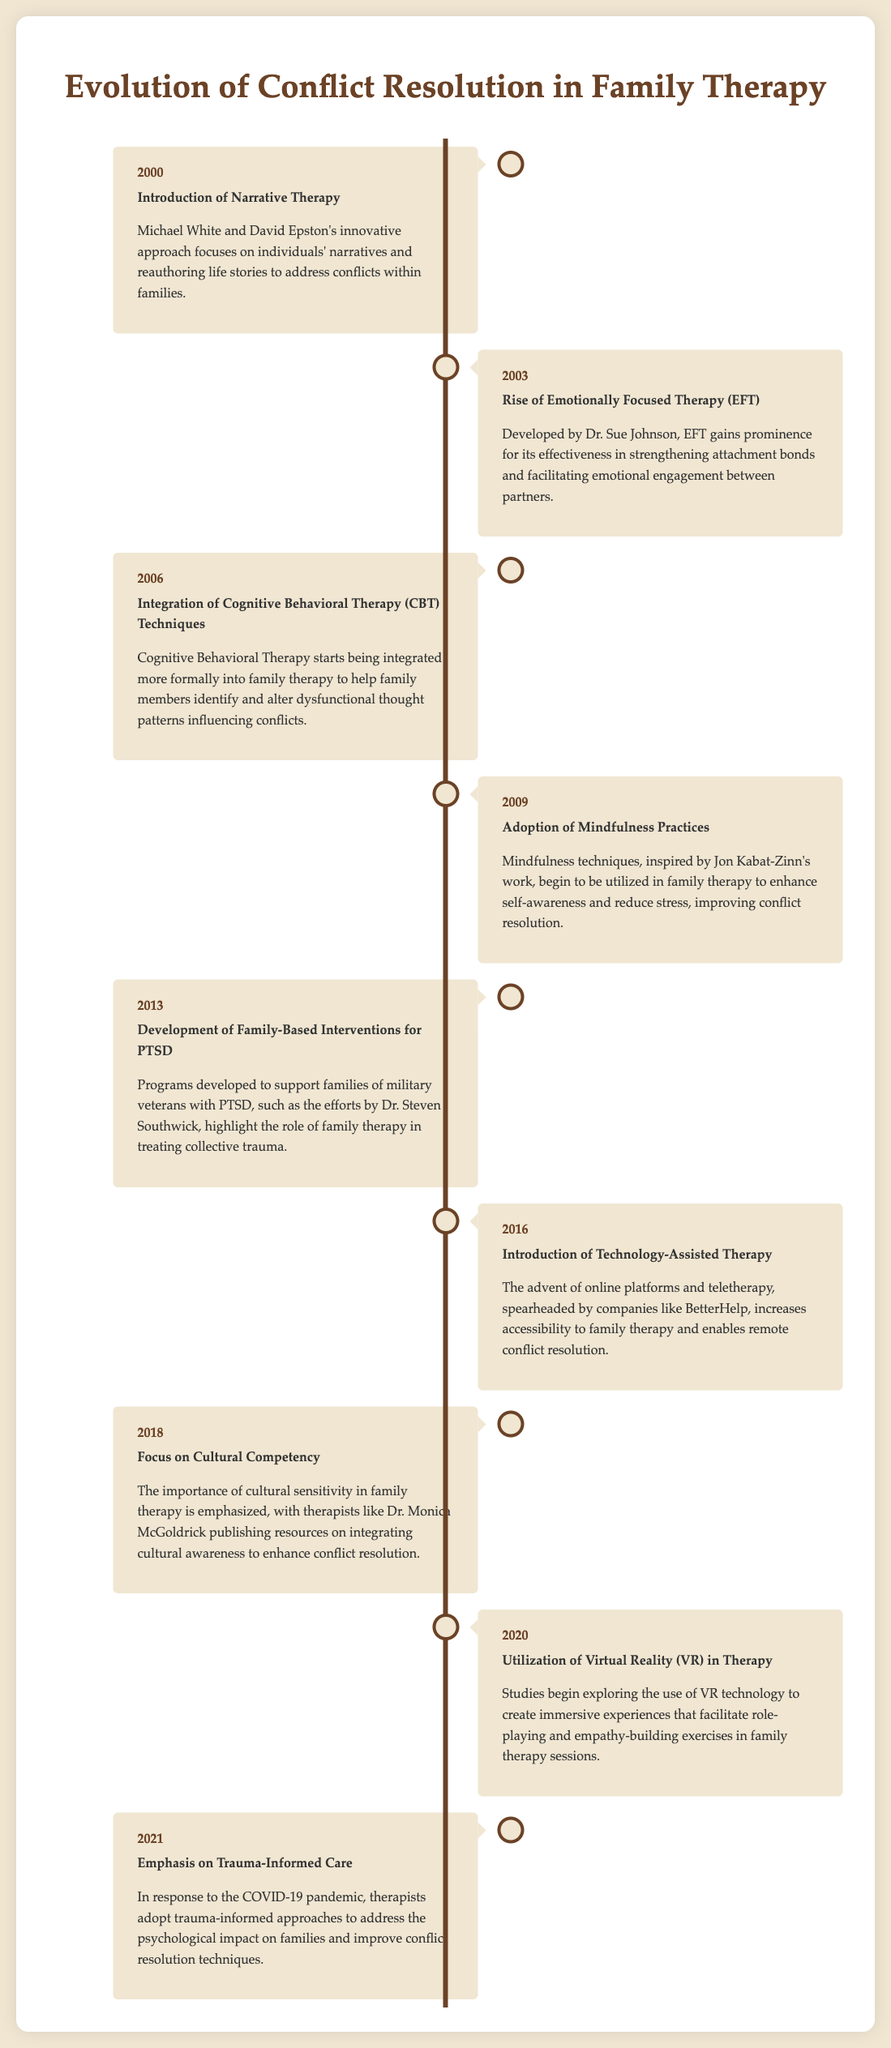What is the first milestone in the timeline? The timeline starts with the introduction of Narrative Therapy in the year 2000.
Answer: Introduction of Narrative Therapy Who developed Emotionally Focused Therapy? The document states that Dr. Sue Johnson developed Emotionally Focused Therapy in 2003.
Answer: Dr. Sue Johnson What year did mindfulness practices begin to be adopted in therapy? According to the timeline, mindfulness practices began to be adopted in family therapy in 2009.
Answer: 2009 Which milestone focuses on cultural competency? The timeline mentions a focus on Cultural Competency as a milestone in 2018.
Answer: Focus on Cultural Competency In what year was trauma-informed care emphasized? The emphasis on trauma-informed care in response to COVID-19 took place in the year 2021.
Answer: 2021 How many years apart were the introduction of Narrative Therapy and the rise of Emotionally Focused Therapy? The introduction was in 2000, and EFT rose in 2003, making it a 3-year difference.
Answer: 3 years What approach was used to support families of military veterans with PTSD? The document describes the development of Family-Based Interventions for PTSD for families of military veterans.
Answer: Family-Based Interventions for PTSD What technology was introduced to assist therapy in 2016? The timeline indicates that Technology-Assisted Therapy was introduced in 2016, which refers to online platforms and teletherapy.
Answer: Technology-Assisted Therapy Which year marks the exploration of Virtual Reality in therapy? The use of VR technology in therapy began being explored in the year 2020.
Answer: 2020 